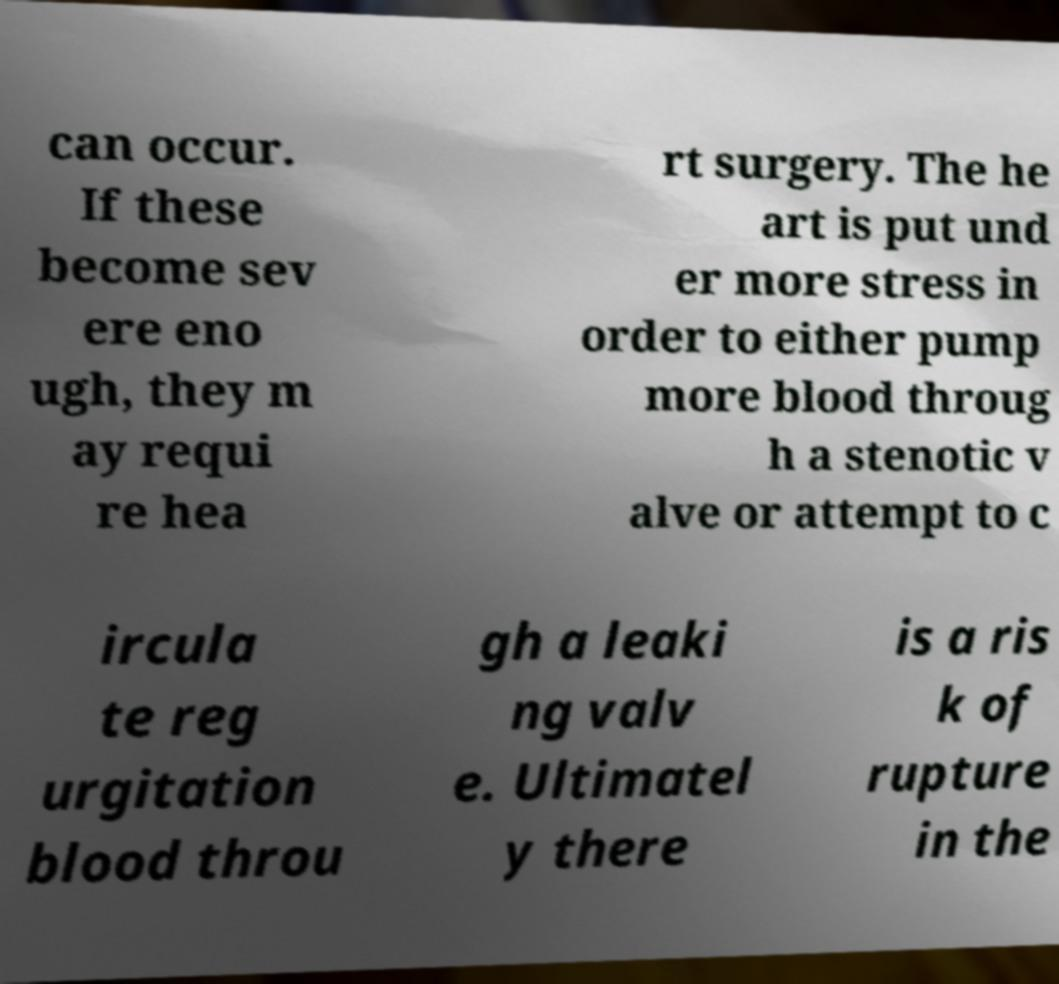Could you assist in decoding the text presented in this image and type it out clearly? can occur. If these become sev ere eno ugh, they m ay requi re hea rt surgery. The he art is put und er more stress in order to either pump more blood throug h a stenotic v alve or attempt to c ircula te reg urgitation blood throu gh a leaki ng valv e. Ultimatel y there is a ris k of rupture in the 